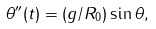Convert formula to latex. <formula><loc_0><loc_0><loc_500><loc_500>\theta ^ { \prime \prime } ( t ) = ( g / R _ { 0 } ) \sin \theta ,</formula> 